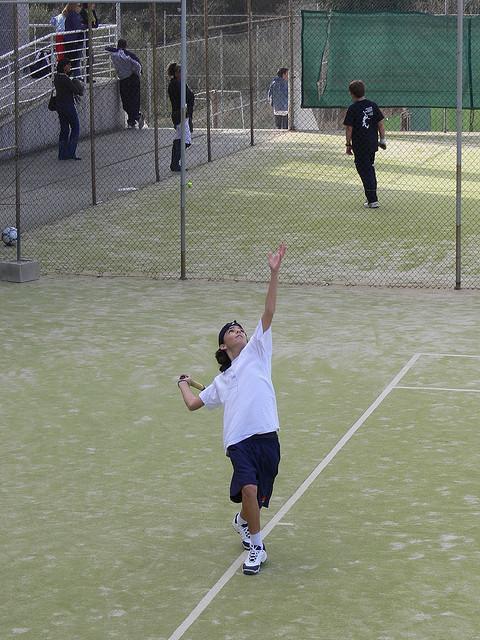How many people are there?
Give a very brief answer. 3. 